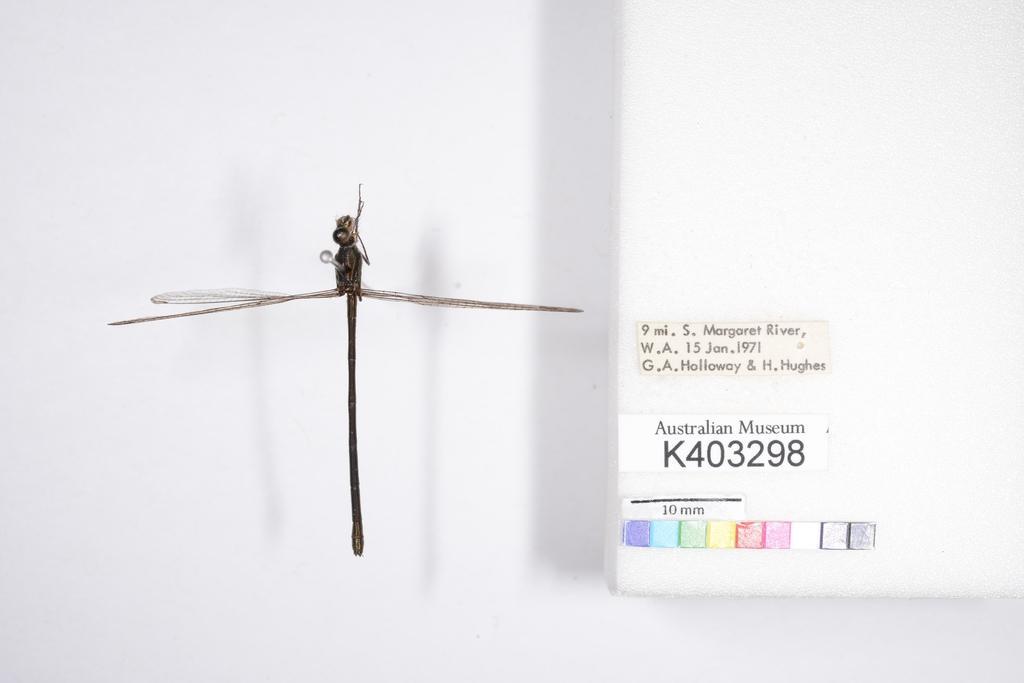How would you summarize this image in a sentence or two? In this image I can see the insect and I can see the white color object and few stickers attached to it. Background is in white color. 